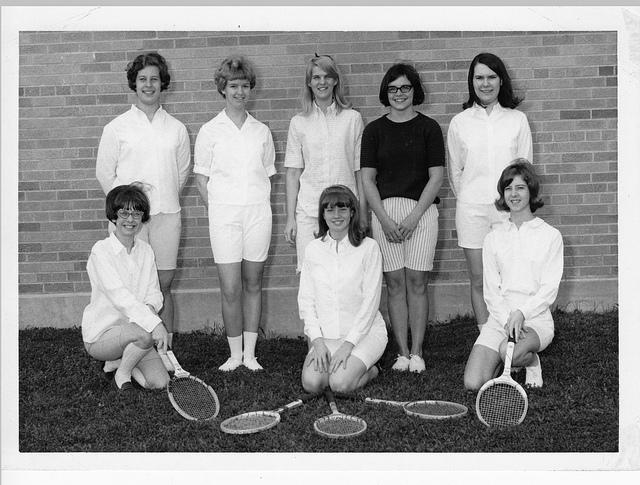How many people are there?
Answer briefly. 8. What is laying on the grass in front of the women?
Quick response, please. Tennis rackets. How many women have a dark shirt?
Keep it brief. 1. 